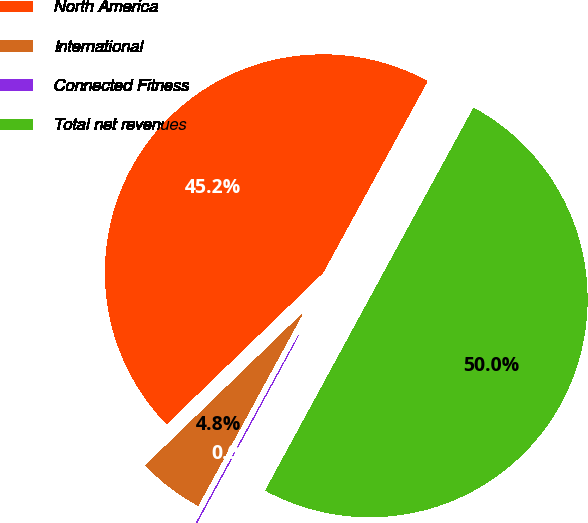Convert chart to OTSL. <chart><loc_0><loc_0><loc_500><loc_500><pie_chart><fcel>North America<fcel>International<fcel>Connected Fitness<fcel>Total net revenues<nl><fcel>45.18%<fcel>4.82%<fcel>0.02%<fcel>49.98%<nl></chart> 